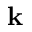<formula> <loc_0><loc_0><loc_500><loc_500>k</formula> 